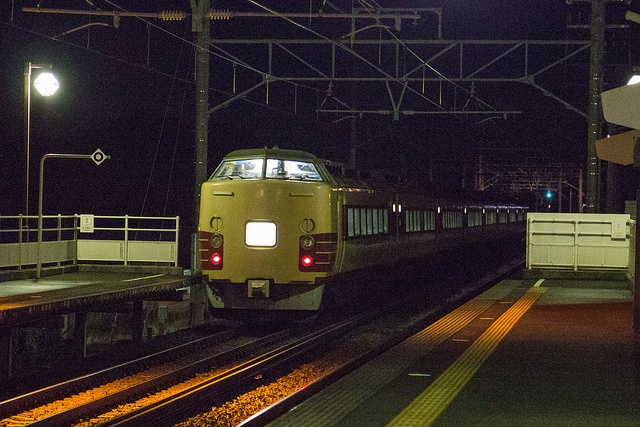Describe the objects in this image and their specific colors. I can see a train in black, olive, gray, and white tones in this image. 